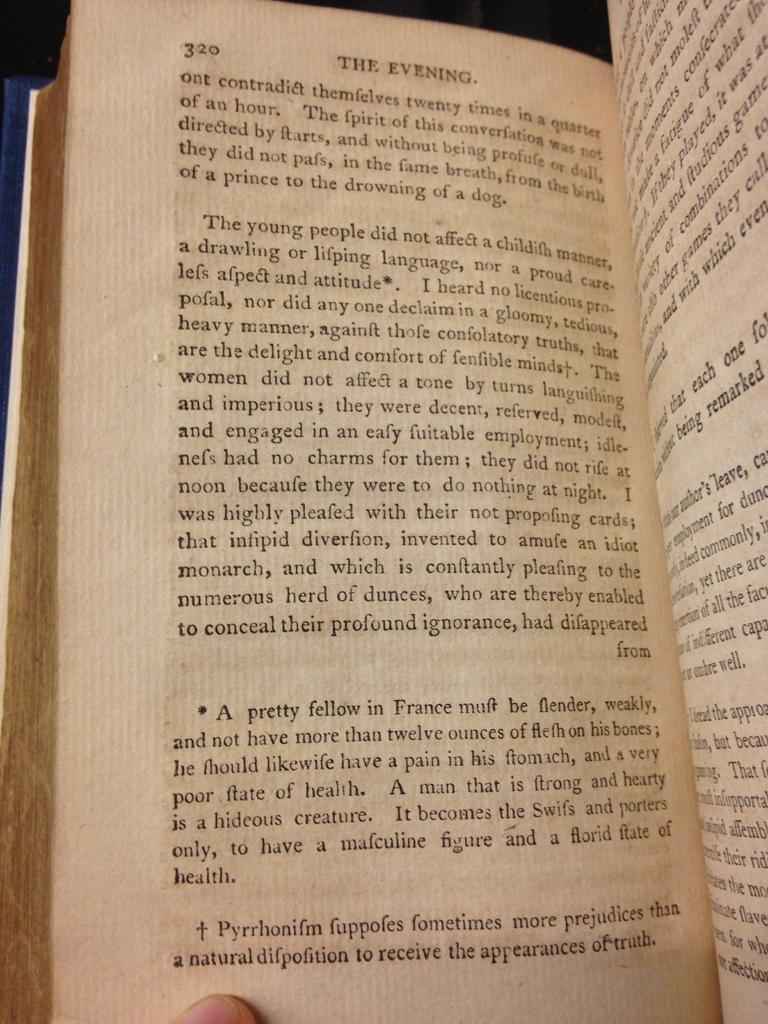What is the main subject of the image? The main subject of the image is a book. What can be found inside the book? There is matter in the book in the image. What part of a person is visible in the image? There is a human finger visible at the bottom of the image. Where is the robin perched in the image? There is no robin present in the image. What type of office furniture can be seen in the image? There is no office furniture present in the image. 